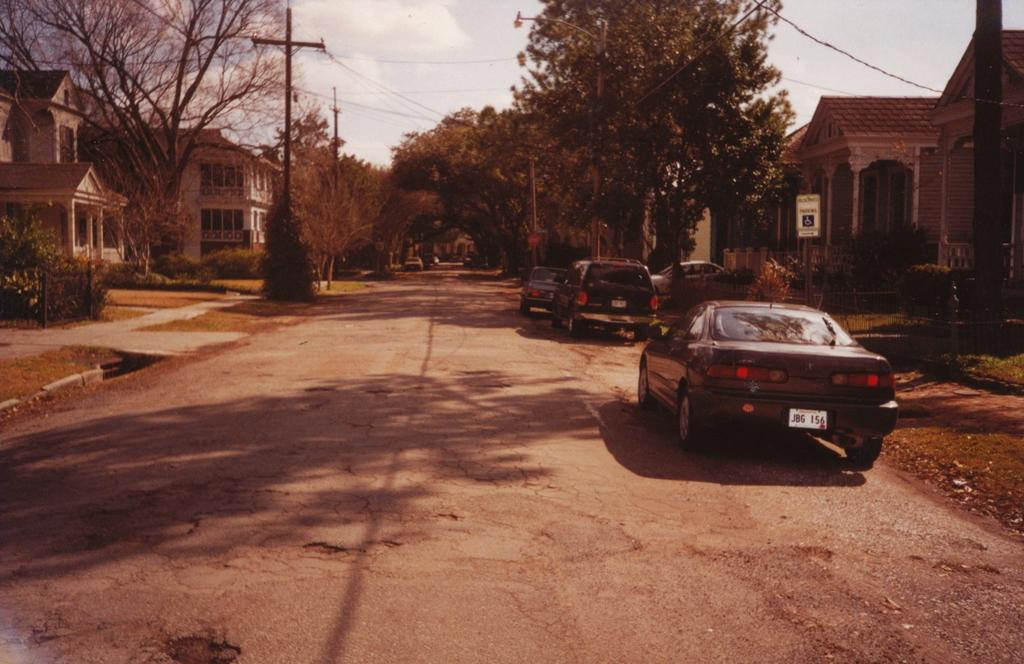What can be seen on the road in the image? There are cars on the road in the image. What type of natural elements are visible in the background? There are trees in the background of the image. What structures can be seen in the background? There are poles and buildings in the background of the image. What part of the natural environment is visible in the image? The sky is visible in the background of the image. Can you tell me what office the stranger is working in, as seen in the image? There is no office or stranger present in the image; it features cars on the road with trees, poles, buildings, and the sky in the background. 